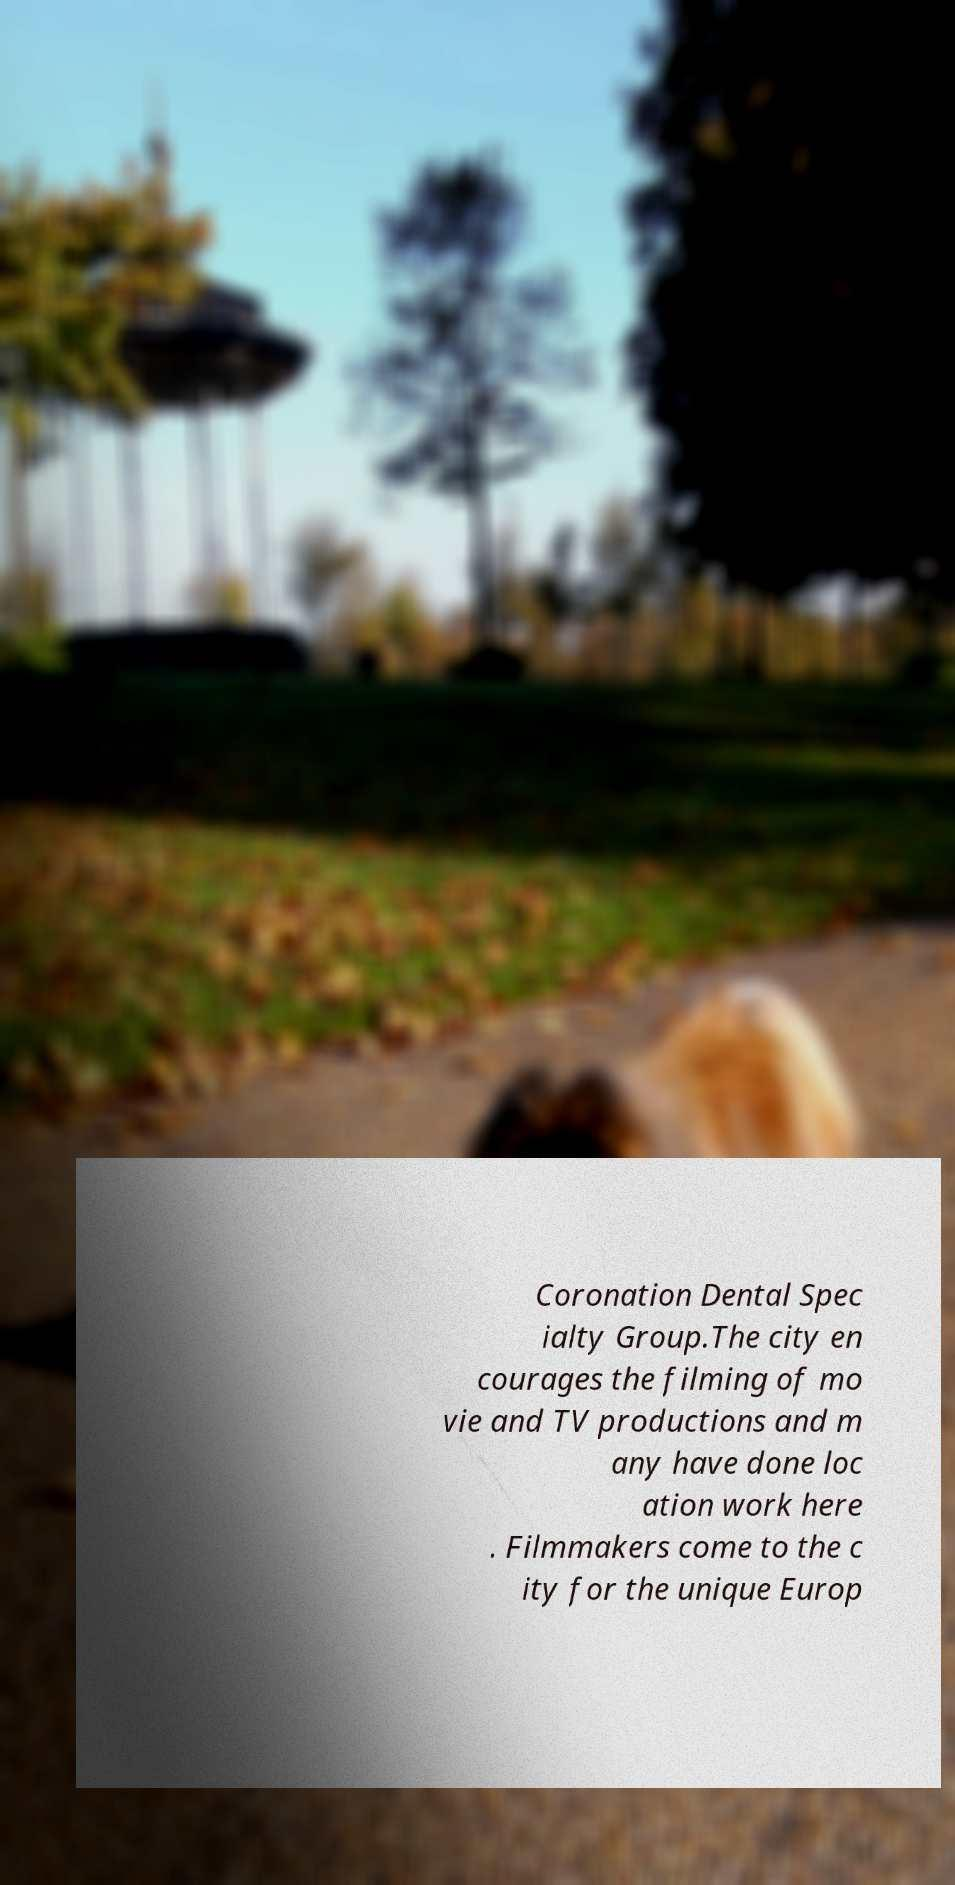I need the written content from this picture converted into text. Can you do that? Coronation Dental Spec ialty Group.The city en courages the filming of mo vie and TV productions and m any have done loc ation work here . Filmmakers come to the c ity for the unique Europ 